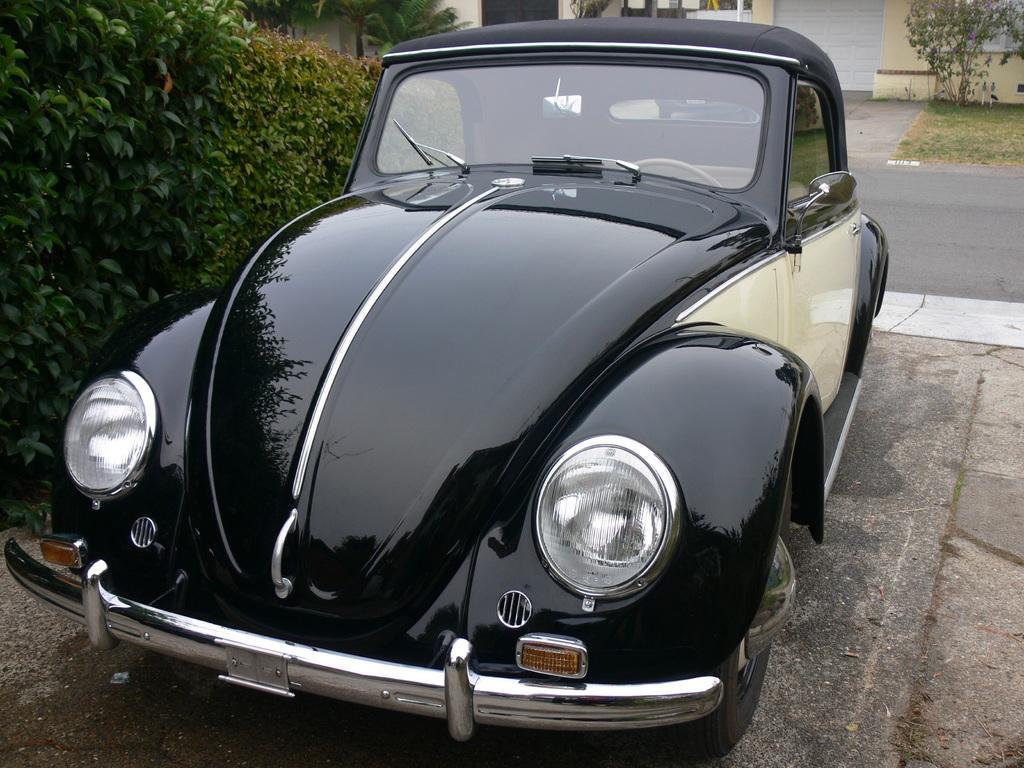In one or two sentences, can you explain what this image depicts? In this picture i can see a black color car on the ground. On the left side i can see plants. In the background i can see road, shutter, wall, grass and tree. 